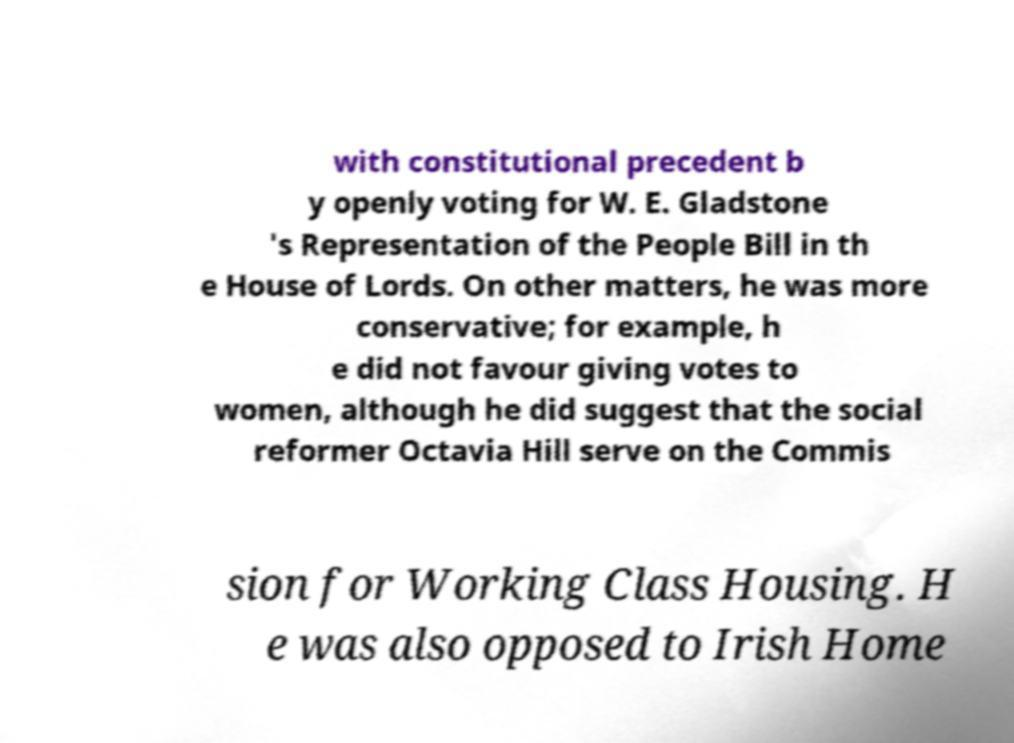Please identify and transcribe the text found in this image. with constitutional precedent b y openly voting for W. E. Gladstone 's Representation of the People Bill in th e House of Lords. On other matters, he was more conservative; for example, h e did not favour giving votes to women, although he did suggest that the social reformer Octavia Hill serve on the Commis sion for Working Class Housing. H e was also opposed to Irish Home 